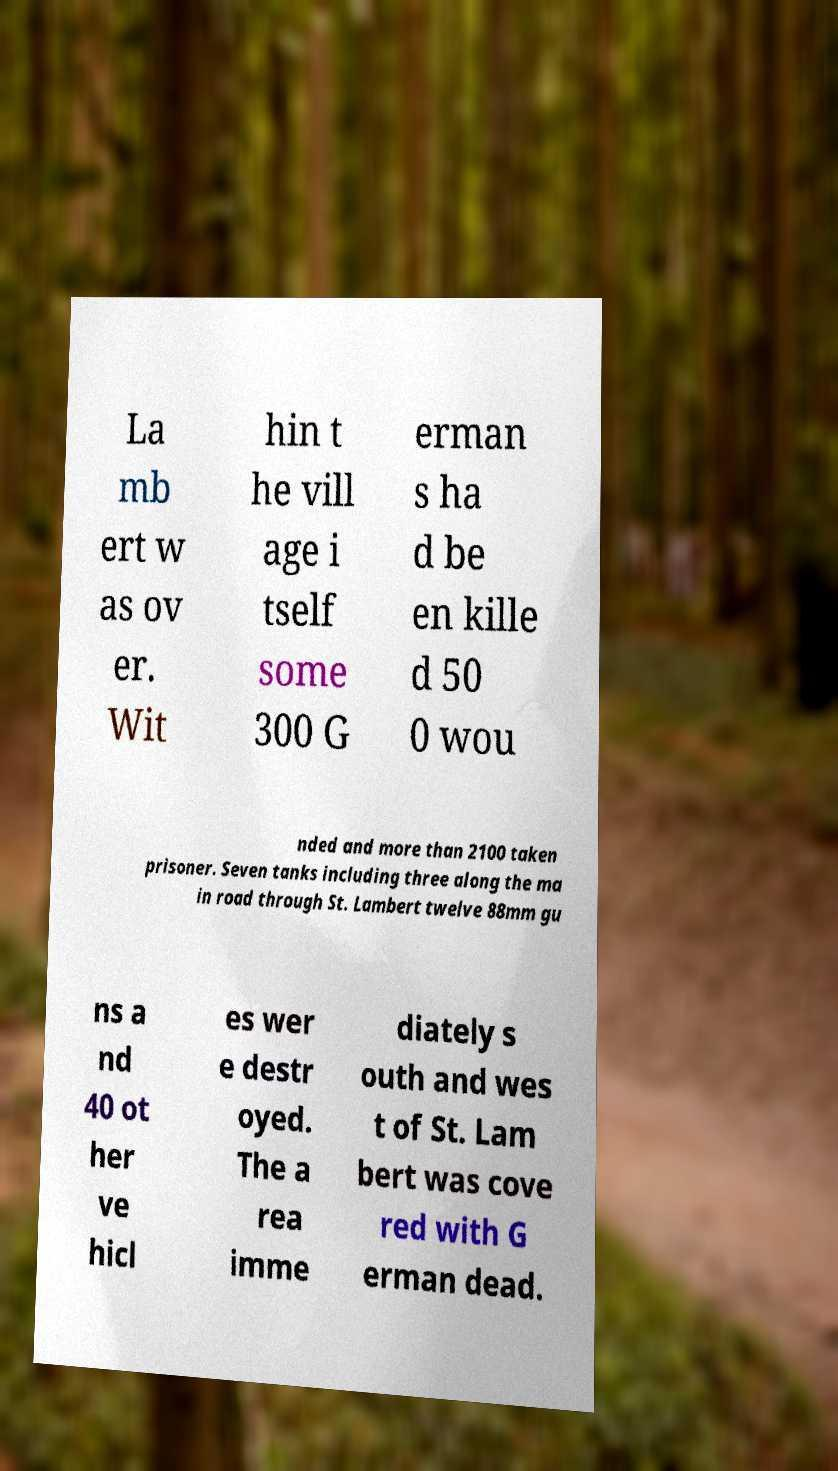For documentation purposes, I need the text within this image transcribed. Could you provide that? La mb ert w as ov er. Wit hin t he vill age i tself some 300 G erman s ha d be en kille d 50 0 wou nded and more than 2100 taken prisoner. Seven tanks including three along the ma in road through St. Lambert twelve 88mm gu ns a nd 40 ot her ve hicl es wer e destr oyed. The a rea imme diately s outh and wes t of St. Lam bert was cove red with G erman dead. 